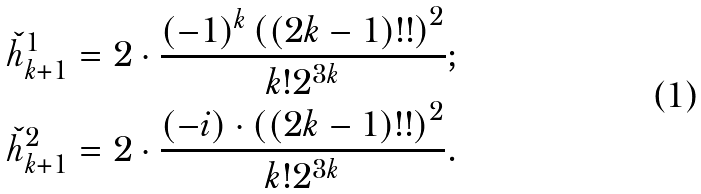<formula> <loc_0><loc_0><loc_500><loc_500>\check { h } ^ { 1 } _ { k + 1 } & = 2 \cdot \frac { ( - 1 ) ^ { k } \left ( ( 2 k - 1 ) ! ! \right ) ^ { 2 } } { k ! 2 ^ { 3 k } } ; \\ \check { h } ^ { 2 } _ { k + 1 } & = 2 \cdot \frac { ( - i ) \cdot \left ( ( 2 k - 1 ) ! ! \right ) ^ { 2 } } { k ! 2 ^ { 3 k } } .</formula> 